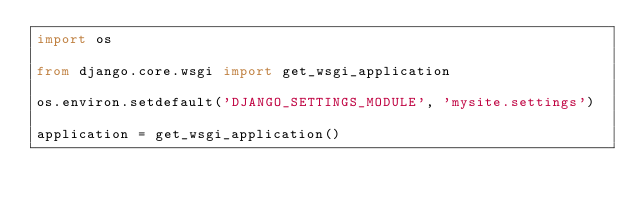<code> <loc_0><loc_0><loc_500><loc_500><_Python_>import os

from django.core.wsgi import get_wsgi_application

os.environ.setdefault('DJANGO_SETTINGS_MODULE', 'mysite.settings')

application = get_wsgi_application()
</code> 